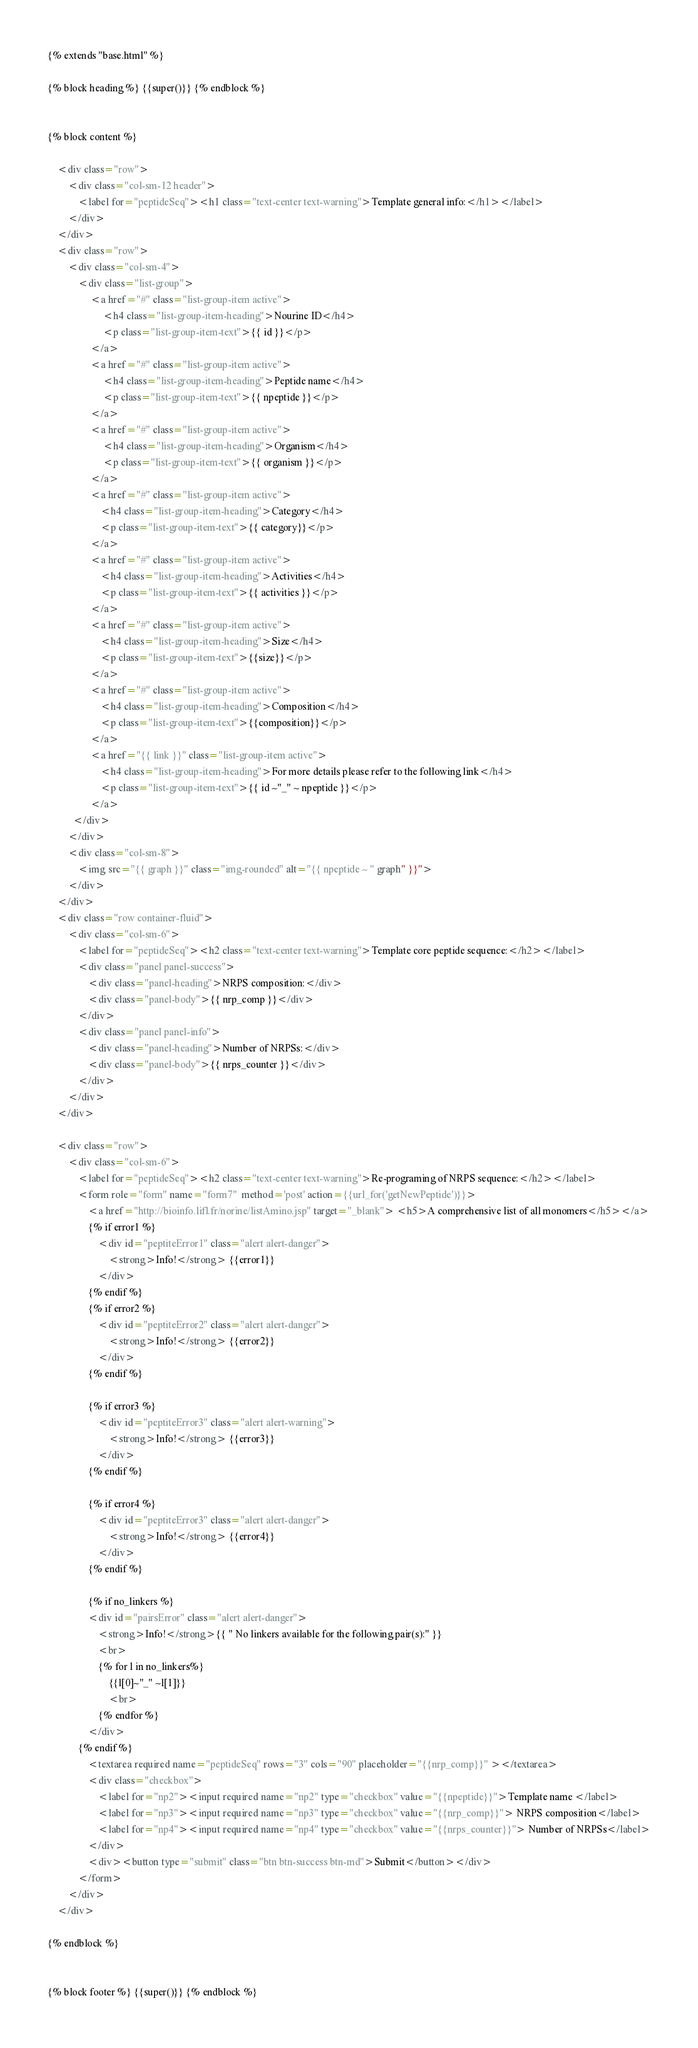Convert code to text. <code><loc_0><loc_0><loc_500><loc_500><_HTML_>{% extends "base.html" %}

{% block heading %} {{super()}} {% endblock %}


{% block content %}

    <div class="row">
        <div class="col-sm-12 header">
            <label for="peptideSeq"><h1 class="text-center text-warning">Template general info:</h1></label>
        </div>
    </div>
    <div class="row">
        <div class="col-sm-4">
            <div class="list-group">
                 <a href="#" class="list-group-item active">
                      <h4 class="list-group-item-heading">Nourine ID</h4>
                      <p class="list-group-item-text">{{ id }}</p>
                 </a>
                 <a href="#" class="list-group-item active">
                      <h4 class="list-group-item-heading">Peptide name</h4>
                      <p class="list-group-item-text">{{ npeptide }}</p>
                 </a>
                 <a href="#" class="list-group-item active">
                      <h4 class="list-group-item-heading">Organism</h4>
                      <p class="list-group-item-text">{{ organism }}</p>
                 </a>
                 <a href="#" class="list-group-item active">
                     <h4 class="list-group-item-heading">Category</h4>
                     <p class="list-group-item-text">{{ category}}</p>
                 </a>
                 <a href="#" class="list-group-item active">
                     <h4 class="list-group-item-heading">Activities</h4>
                     <p class="list-group-item-text">{{ activities }}</p>
                 </a>
                 <a href="#" class="list-group-item active">
                     <h4 class="list-group-item-heading">Size</h4>
                     <p class="list-group-item-text">{{size}}</p>
                 </a>
                 <a href="#" class="list-group-item active">
                     <h4 class="list-group-item-heading">Composition</h4>
                     <p class="list-group-item-text">{{composition}}</p>
                 </a>
                 <a href="{{ link }}" class="list-group-item active">
                     <h4 class="list-group-item-heading">For more details please refer to the following link</h4>
                     <p class="list-group-item-text">{{ id ~"_" ~ npeptide }}</p>
                 </a>
          </div>
        </div>
        <div class="col-sm-8">
            <img src="{{ graph }}" class="img-rounded" alt="{{ npeptide ~ " graph" }}">
        </div>
    </div>
    <div class="row container-fluid">
        <div class="col-sm-6">
            <label for="peptideSeq"><h2 class="text-center text-warning">Template core peptide sequence:</h2></label>
            <div class="panel panel-success">
                <div class="panel-heading">NRPS composition:</div>
                <div class="panel-body">{{ nrp_comp }}</div>
            </div>
            <div class="panel panel-info">
                <div class="panel-heading">Number of NRPSs:</div>
                <div class="panel-body">{{ nrps_counter }}</div>
            </div>
        </div>
    </div>

    <div class="row">
        <div class="col-sm-6">
            <label for="peptideSeq"><h2 class="text-center text-warning">Re-programing of NRPS sequence:</h2></label>
            <form role="form" name="form7"  method='post' action={{url_for('getNewPeptide')}}>
                <a href="http://bioinfo.lifl.fr/norine/listAmino.jsp" target="_blank"> <h5>A comprehensive list of all monomers</h5></a>
                {% if error1 %}
                    <div id="peptiteError1" class="alert alert-danger">
                        <strong>Info!</strong> {{error1}}
                    </div>
                {% endif %}
                {% if error2 %}
                    <div id="peptiteError2" class="alert alert-danger">
                        <strong>Info!</strong> {{error2}}
                    </div>
                {% endif %}

                {% if error3 %}
                    <div id="peptiteError3" class="alert alert-warning">
                        <strong>Info!</strong> {{error3}}
                    </div>
                {% endif %}

                {% if error4 %}
                    <div id="peptiteError3" class="alert alert-danger">
                        <strong>Info!</strong> {{error4}}
                    </div>
                {% endif %}

                {% if no_linkers %}
                <div id="pairsError" class="alert alert-danger">
                    <strong>Info!</strong>{{ " No linkers available for the following pair(s):" }}
                    <br>
                    {% for l in no_linkers%}
                        {{l[0]~"_" ~l[1]}}
                        <br>
                    {% endfor %}
                </div>
            {% endif %}
                <textarea required name="peptideSeq" rows="3" cols="90" placeholder="{{nrp_comp}}" ></textarea>
                <div class="checkbox">
                    <label for="np2"><input required name="np2" type="checkbox" value="{{npeptide}}">Template name </label>
                    <label for="np3"><input required name="np3" type="checkbox" value="{{nrp_comp}}"> NRPS composition</label>
                    <label for="np4"><input required name="np4" type="checkbox" value="{{nrps_counter}}"> Number of NRPSs</label>
                </div>
                <div><button type="submit" class="btn btn-success btn-md">Submit</button></div>
            </form>
        </div>
    </div>

{% endblock %}


{% block footer %} {{super()}} {% endblock %}
</code> 